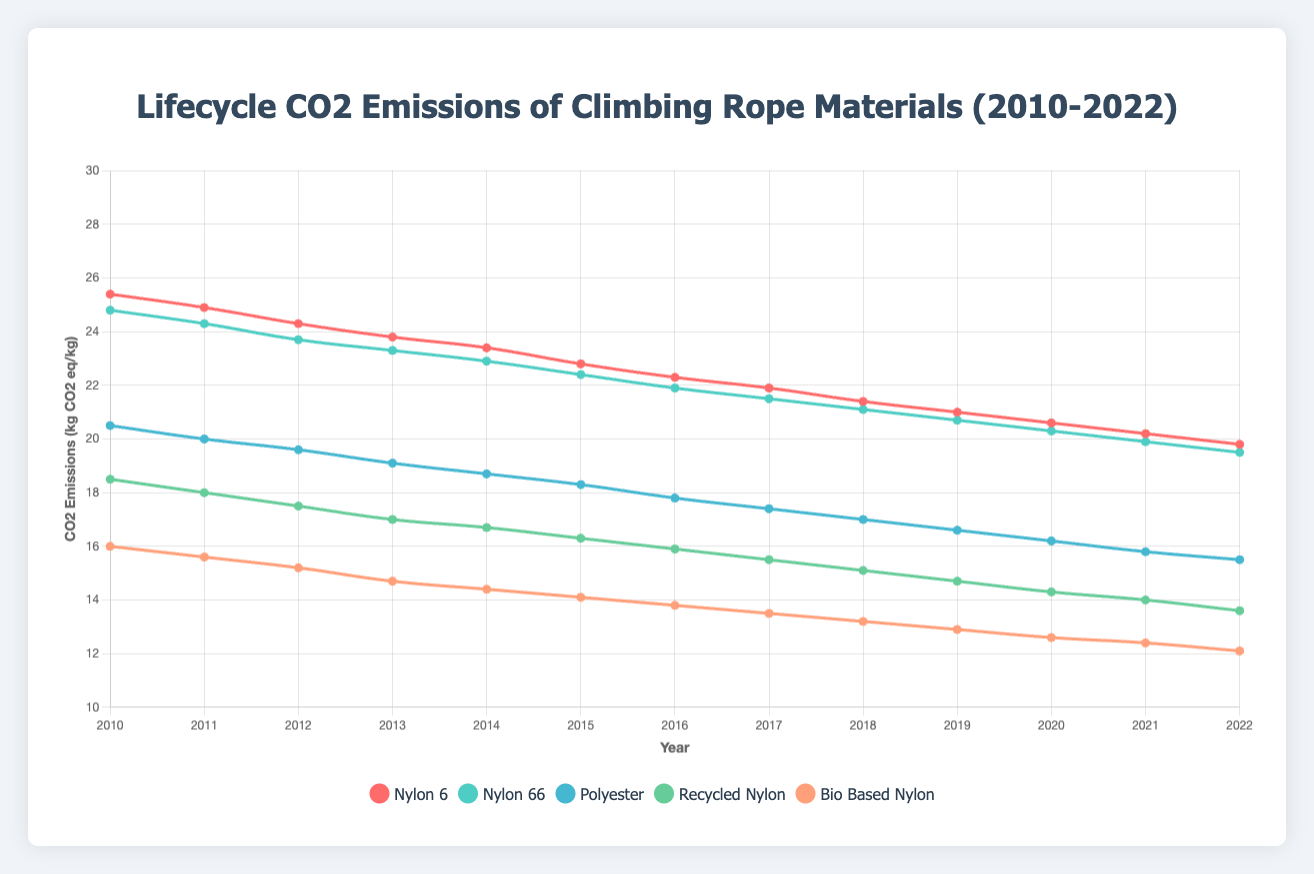What's the highest CO2 emission value recorded for nylon 6 and in which year did it occur? The highest CO2 emission value for nylon 6 is found by looking at the emission values for all years. From 2010 to 2022, the highest value is 25.4 kg CO2 eq/kg, which occurred in 2010.
Answer: 25.4 in 2010 Which material shows the greatest reduction in CO2 emissions between 2010 and 2022? By comparing the CO2 emission values of each material from 2010 to 2022, we can calculate the differences: 
- Nylon 6 reduction is 25.4 - 19.8 = 5.6 
- Nylon 66 reduction is 24.8 - 19.5 = 5.3 
- Polyester reduction is 20.5 - 15.5 = 5.0 
- Recycled Nylon reduction is 18.5 - 13.6 = 4.9 
- Bio-based Nylon reduction is 16.0 - 12.1 = 3.9 
The greatest reduction is for nylon 6 with a difference of 5.6.
Answer: Nylon 6 In what year do nylon 6 and nylon 66 first show less than 22 kg CO2 eq/kg emissions? Referring to the emission values, we see that in 2019 both nylon 6 (21.0) and nylon 66 (20.7) first drop below 22 kg CO2 eq/kg emissions.
Answer: 2019 What is the average CO2 emission value for bio-based nylon from 2010 to 2022? To find the average, sum up the annual emissions for bio-based nylon and divide by the number of years: 
(16.0 + 15.6 + 15.2 + 14.7 + 14.4 + 14.1 + 13.8 + 13.5 + 13.2 + 12.9 + 12.6 + 12.4 + 12.1) = 180.5 
Then divide by 13 years: 180.5 / 13 ≈ 13.88 kg CO2 eq/kg
Answer: 13.88 Which material had the least CO2 emissions in 2022? By examining the emission values for each material in 2022, bio-based nylon has the lowest emissions of 12.1 kg CO2 eq/kg compared to others.
Answer: Bio-based nylon How much have polyester emissions decreased from 2010 to 2017? Identify the emissions for polyester in 2010 (20.5) and in 2017 (17.4), and calculate the difference: 20.5 - 17.4 = 3.1 kg CO2 eq/kg.
Answer: 3.1 What trend do the CO2 emission values show for recycled nylon from 2010 to 2022? Observing the data for recycled nylon, emissions consistently decrease year by year from 18.5 in 2010 to 13.6 in 2022, indicating a downward trend.
Answer: Downward trend Between which consecutive years do we see the steepest decline for nylon 66 emissions? We need to calculate the annual changes and identify the steepest decline:
- 2010-2011: 24.8 - 24.3 = 0.5 
- 2011-2012: 24.3 - 23.7 = 0.6 
- 2012-2013: 23.7 - 23.3 = 0.4 
- 2013-2014: 23.3 - 22.9 = 0.4 
- 2014-2015: 22.9 - 22.4 = 0.5 
- 2015-2016: 22.4 - 21.9 = 0.5 
- 2016-2017: 21.9 - 21.5 = 0.4 
- 2017-2018: 21.5 - 21.1 = 0.4 
- 2018-2019: 21.1 - 20.7 = 0.4 
- 2019-2020: 20.7 - 20.3 = 0.4 
- 2020-2021: 20.3 - 19.9 = 0.4 
- 2021-2022: 19.9 - 19.5 = 0.4 
The steepest decline of 0.6 occurs between 2011 and 2012.
Answer: 2011-2012 What's the total CO2 emission reduction for all materials from 2010 to 2022 combined? Calculate the reduction for each material and sum them up:
- Nylon 6: 25.4 - 19.8 = 5.6 
- Nylon 66: 24.8 - 19.5 = 5.3 
- Polyester: 20.5 - 15.5 = 5.0 
- Recycled Nylon: 18.5 - 13.6 = 4.9 
- Bio-based Nylon: 16.0 - 12.1 = 3.9 
Total reduction = 5.6 + 5.3 + 5.0 + 4.9 + 3.9 = 24.7 kg CO2 eq/kg
Answer: 24.7 